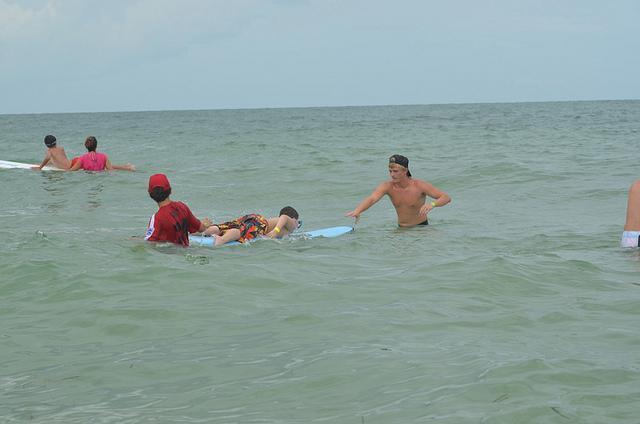How many people are in the picture?
Give a very brief answer. 3. 